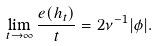<formula> <loc_0><loc_0><loc_500><loc_500>\lim _ { t \to \infty } \frac { e ( h _ { t } ) } { t } = 2 \nu ^ { - 1 } | \phi | .</formula> 